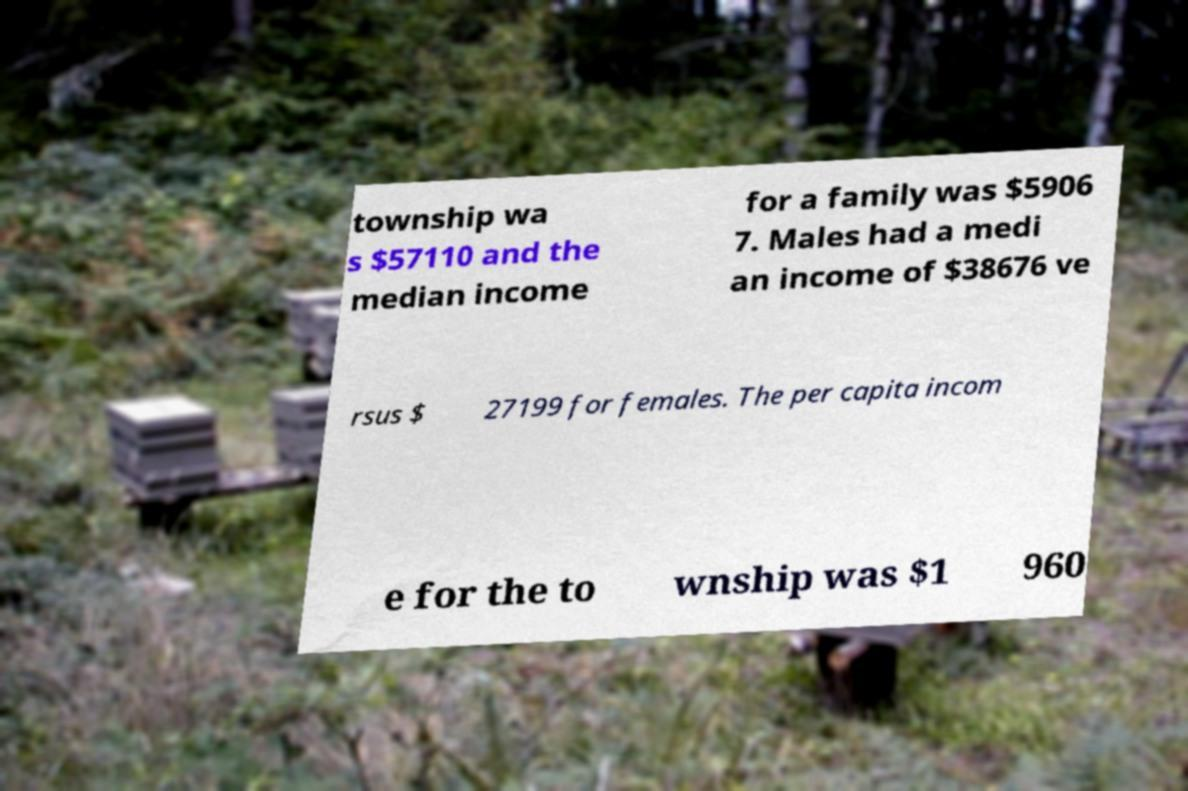For documentation purposes, I need the text within this image transcribed. Could you provide that? township wa s $57110 and the median income for a family was $5906 7. Males had a medi an income of $38676 ve rsus $ 27199 for females. The per capita incom e for the to wnship was $1 960 